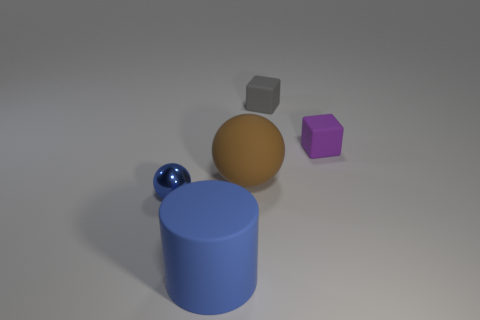Add 3 small purple blocks. How many small purple blocks are left? 4 Add 4 gray metal spheres. How many gray metal spheres exist? 4 Add 2 big blue rubber objects. How many objects exist? 7 Subtract all blue balls. How many balls are left? 1 Subtract 0 purple balls. How many objects are left? 5 Subtract all balls. How many objects are left? 3 Subtract 2 balls. How many balls are left? 0 Subtract all purple cylinders. Subtract all blue cubes. How many cylinders are left? 1 Subtract all brown cylinders. How many red cubes are left? 0 Subtract all green cylinders. Subtract all gray blocks. How many objects are left? 4 